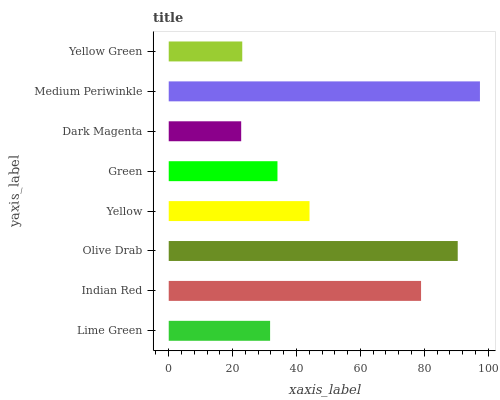Is Dark Magenta the minimum?
Answer yes or no. Yes. Is Medium Periwinkle the maximum?
Answer yes or no. Yes. Is Indian Red the minimum?
Answer yes or no. No. Is Indian Red the maximum?
Answer yes or no. No. Is Indian Red greater than Lime Green?
Answer yes or no. Yes. Is Lime Green less than Indian Red?
Answer yes or no. Yes. Is Lime Green greater than Indian Red?
Answer yes or no. No. Is Indian Red less than Lime Green?
Answer yes or no. No. Is Yellow the high median?
Answer yes or no. Yes. Is Green the low median?
Answer yes or no. Yes. Is Medium Periwinkle the high median?
Answer yes or no. No. Is Yellow Green the low median?
Answer yes or no. No. 